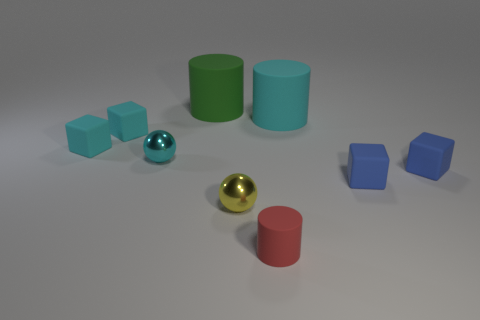There is another large object that is the same shape as the big green thing; what is its color?
Offer a very short reply. Cyan. Are the big cyan thing and the cylinder left of the red cylinder made of the same material?
Your response must be concise. Yes. What is the color of the tiny cylinder?
Keep it short and to the point. Red. The large rubber thing that is left of the tiny sphere to the right of the large thing that is left of the tiny cylinder is what color?
Provide a short and direct response. Green. Do the green rubber thing and the small yellow shiny object left of the big cyan rubber cylinder have the same shape?
Give a very brief answer. No. There is a cylinder that is both behind the red rubber thing and in front of the green rubber cylinder; what color is it?
Give a very brief answer. Cyan. Is there another small yellow shiny object that has the same shape as the tiny yellow object?
Your answer should be compact. No. Is there a tiny cyan rubber object to the right of the big thing to the right of the red rubber cylinder?
Your answer should be compact. No. How many things are big matte things behind the cyan cylinder or small cubes to the right of the small red rubber thing?
Provide a succinct answer. 3. What number of things are tiny yellow rubber things or rubber objects that are on the left side of the tiny rubber cylinder?
Your response must be concise. 3. 